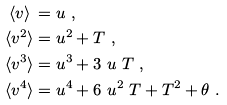<formula> <loc_0><loc_0><loc_500><loc_500>\langle v \rangle \, & = u \ , \\ \langle v ^ { 2 } \rangle & = u ^ { 2 } + T \ , \\ \langle v ^ { 3 } \rangle & = u ^ { 3 } + 3 \ u \ T \ , \\ \langle v ^ { 4 } \rangle & = u ^ { 4 } + 6 \ u ^ { 2 } \ T + T ^ { 2 } + \theta \ .</formula> 